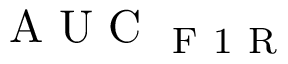Convert formula to latex. <formula><loc_0><loc_0><loc_500><loc_500>A U C _ { F 1 R }</formula> 